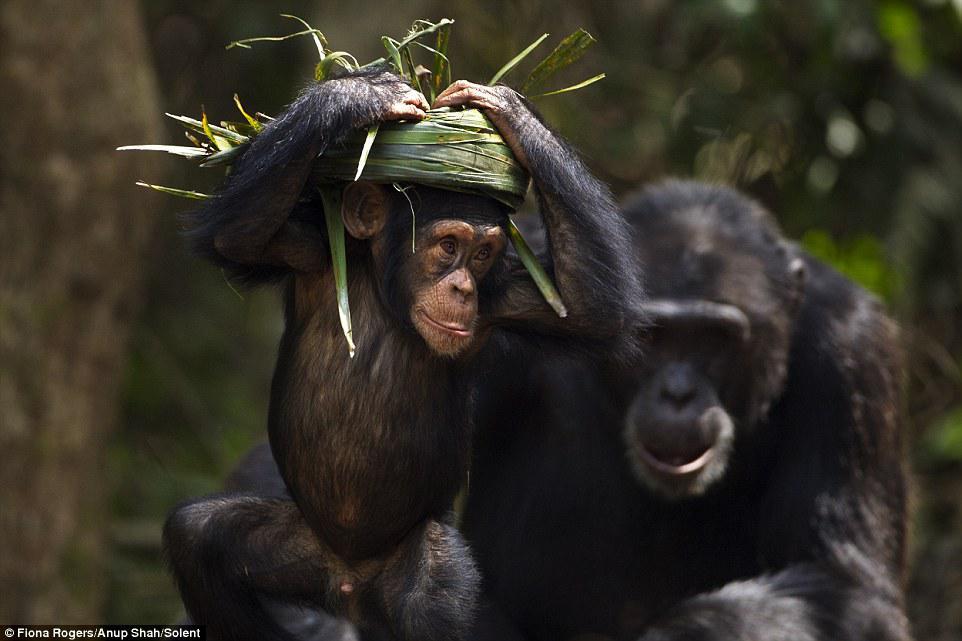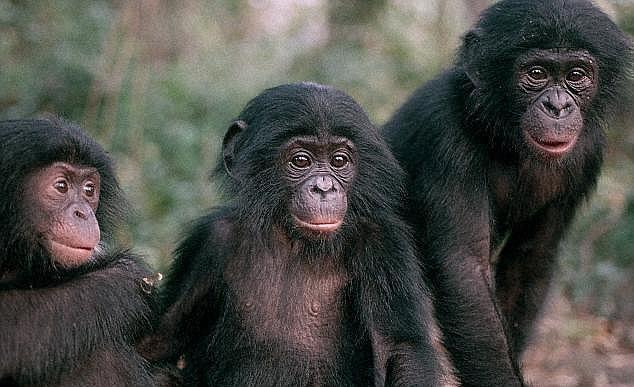The first image is the image on the left, the second image is the image on the right. Assess this claim about the two images: "The lefthand image includes an adult chimp and a small juvenile chimp.". Correct or not? Answer yes or no. Yes. The first image is the image on the left, the second image is the image on the right. Given the left and right images, does the statement "There is a chimpanzee showing something in his hand to two other chimpanzees in the right image." hold true? Answer yes or no. No. 